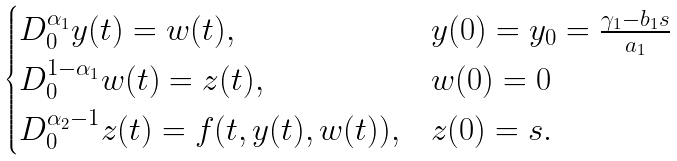Convert formula to latex. <formula><loc_0><loc_0><loc_500><loc_500>\begin{cases} D ^ { \alpha _ { 1 } } _ { 0 } y ( t ) = w ( t ) , & y ( 0 ) = y _ { 0 } = \frac { \gamma _ { 1 } - b _ { 1 } s } { a _ { 1 } } \\ D ^ { 1 - \alpha _ { 1 } } _ { 0 } w ( t ) = z ( t ) , & w ( 0 ) = 0 \\ D ^ { \alpha _ { 2 } - 1 } _ { 0 } z ( t ) = f ( t , y ( t ) , w ( t ) ) , & z ( 0 ) = s . \end{cases}</formula> 